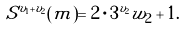<formula> <loc_0><loc_0><loc_500><loc_500>S ^ { v _ { 1 } + v _ { 2 } } ( m ) = 2 \cdot 3 ^ { v _ { 2 } } w _ { 2 } + 1 .</formula> 